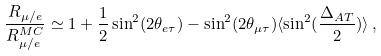Convert formula to latex. <formula><loc_0><loc_0><loc_500><loc_500>\frac { R _ { \mu / e } } { R ^ { M C } _ { \mu / e } } \simeq 1 + \frac { 1 } { 2 } \sin ^ { 2 } ( 2 \theta _ { e \tau } ) - \sin ^ { 2 } ( 2 \theta _ { \mu \tau } ) \langle \sin ^ { 2 } ( \frac { \Delta _ { A T } } { 2 } ) \rangle \, ,</formula> 